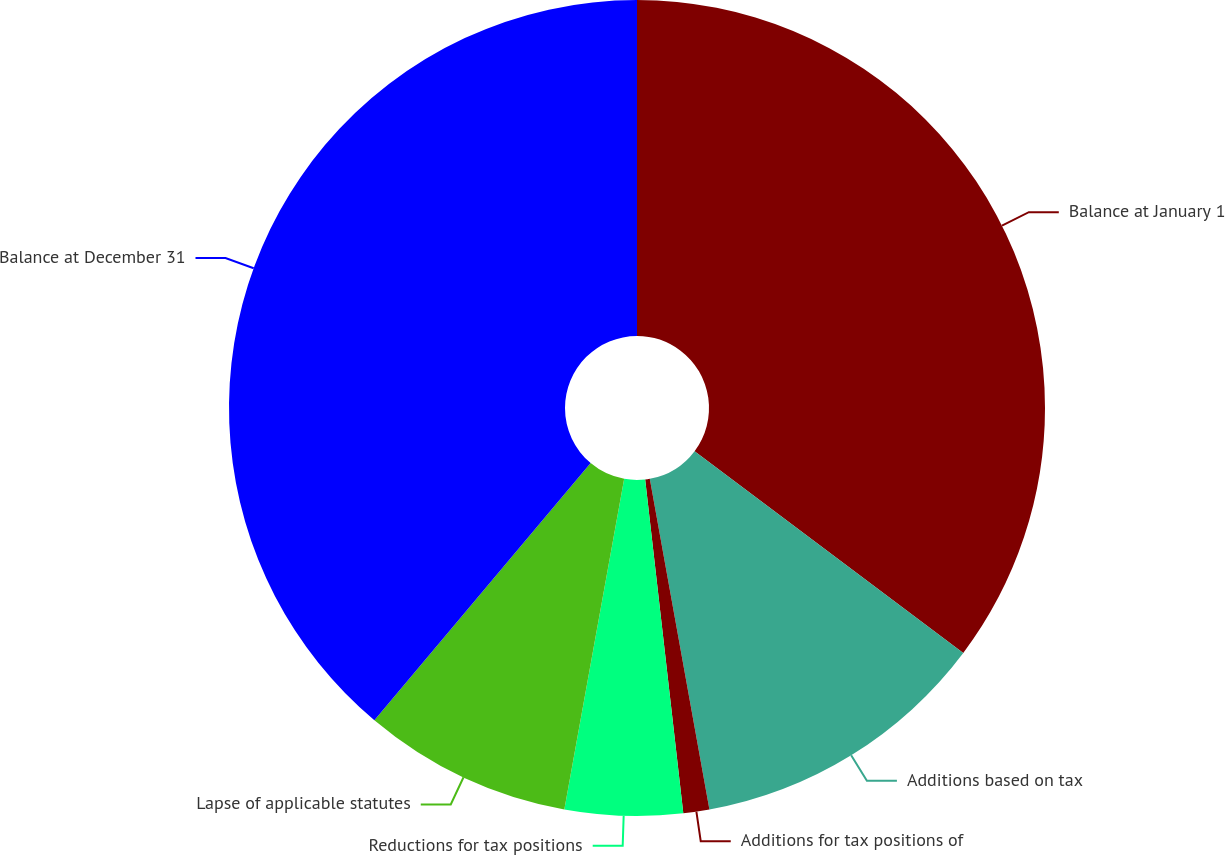Convert chart to OTSL. <chart><loc_0><loc_0><loc_500><loc_500><pie_chart><fcel>Balance at January 1<fcel>Additions based on tax<fcel>Additions for tax positions of<fcel>Reductions for tax positions<fcel>Lapse of applicable statutes<fcel>Balance at December 31<nl><fcel>35.25%<fcel>11.91%<fcel>1.03%<fcel>4.66%<fcel>8.28%<fcel>38.87%<nl></chart> 